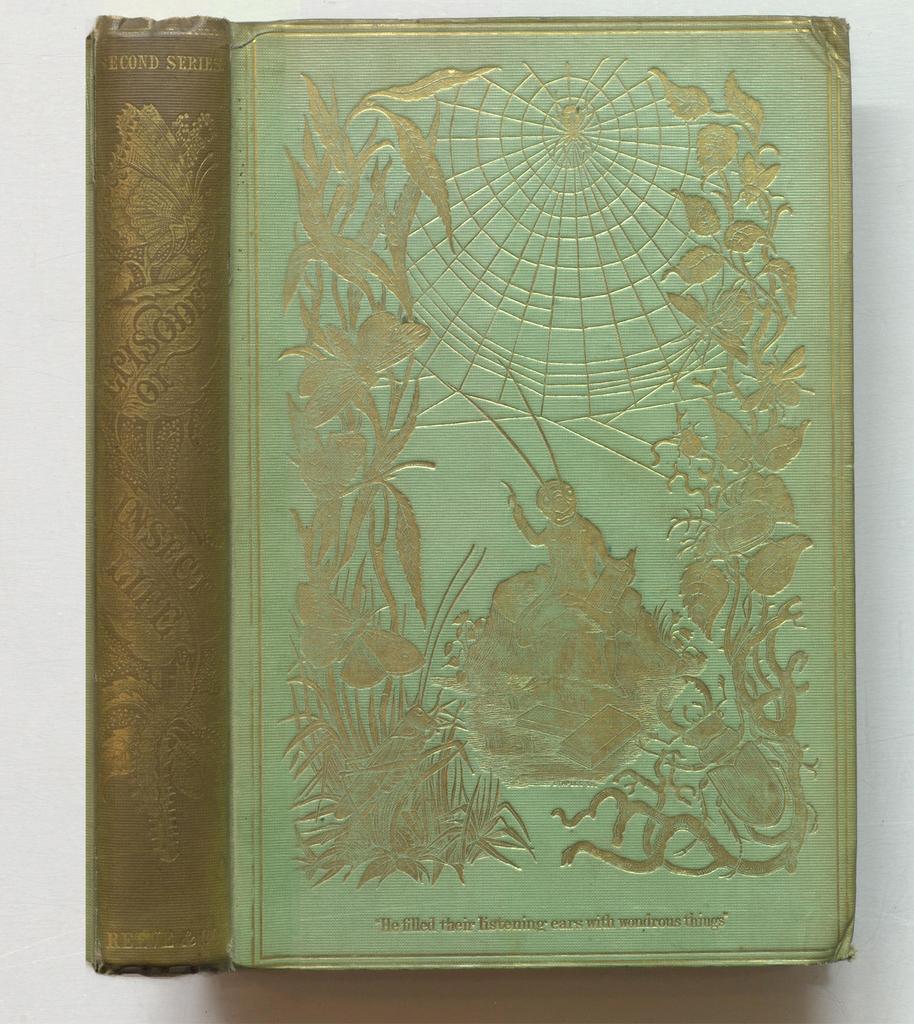Could you give a brief overview of what you see in this image? In this image in the center there is a book on the book there is text and some art, and there is white background. 